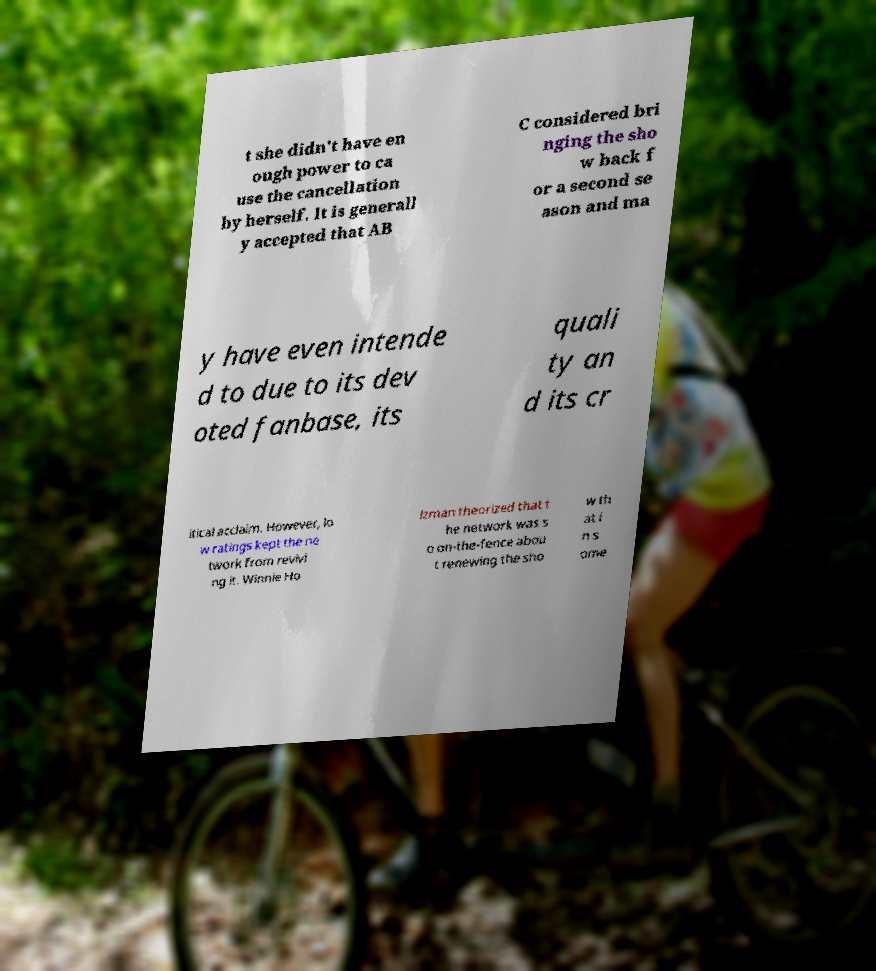Can you read and provide the text displayed in the image?This photo seems to have some interesting text. Can you extract and type it out for me? t she didn't have en ough power to ca use the cancellation by herself. It is generall y accepted that AB C considered bri nging the sho w back f or a second se ason and ma y have even intende d to due to its dev oted fanbase, its quali ty an d its cr itical acclaim. However, lo w ratings kept the ne twork from revivi ng it. Winnie Ho lzman theorized that t he network was s o on-the-fence abou t renewing the sho w th at i n s ome 